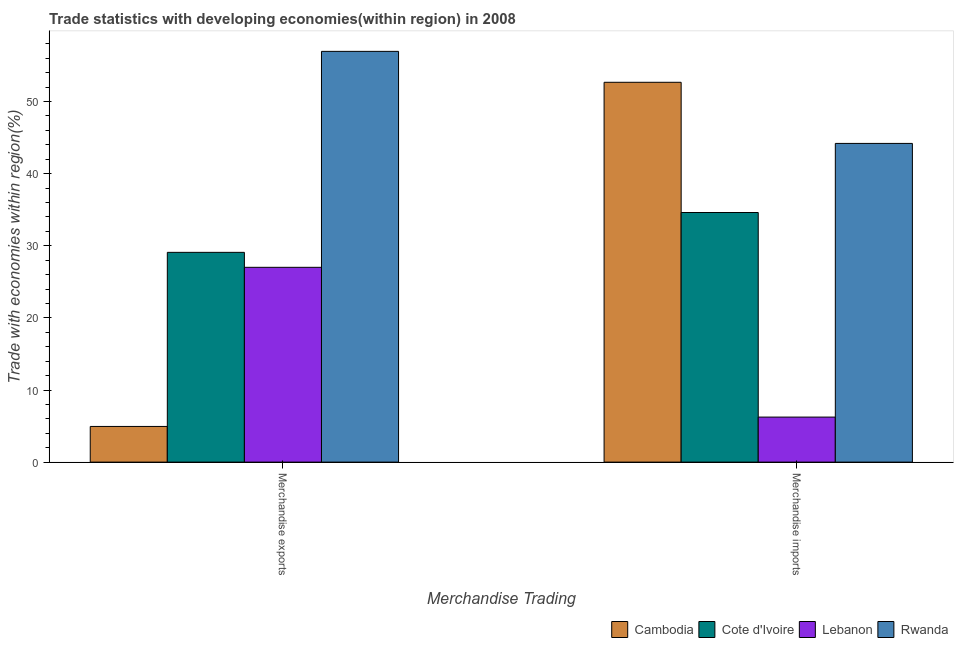How many different coloured bars are there?
Make the answer very short. 4. Are the number of bars per tick equal to the number of legend labels?
Offer a terse response. Yes. Are the number of bars on each tick of the X-axis equal?
Your answer should be compact. Yes. What is the merchandise imports in Lebanon?
Your answer should be very brief. 6.25. Across all countries, what is the maximum merchandise imports?
Ensure brevity in your answer.  52.67. Across all countries, what is the minimum merchandise exports?
Provide a short and direct response. 4.95. In which country was the merchandise imports maximum?
Offer a very short reply. Cambodia. In which country was the merchandise imports minimum?
Give a very brief answer. Lebanon. What is the total merchandise exports in the graph?
Your response must be concise. 118. What is the difference between the merchandise exports in Lebanon and that in Rwanda?
Make the answer very short. -29.94. What is the difference between the merchandise exports in Lebanon and the merchandise imports in Rwanda?
Your answer should be compact. -17.18. What is the average merchandise imports per country?
Make the answer very short. 34.43. What is the difference between the merchandise imports and merchandise exports in Lebanon?
Your answer should be compact. -20.76. What is the ratio of the merchandise exports in Rwanda to that in Lebanon?
Keep it short and to the point. 2.11. Is the merchandise imports in Cambodia less than that in Rwanda?
Offer a very short reply. No. What does the 3rd bar from the left in Merchandise imports represents?
Provide a short and direct response. Lebanon. What does the 2nd bar from the right in Merchandise imports represents?
Offer a very short reply. Lebanon. How many countries are there in the graph?
Ensure brevity in your answer.  4. Does the graph contain any zero values?
Offer a terse response. No. Does the graph contain grids?
Your answer should be compact. No. Where does the legend appear in the graph?
Your answer should be compact. Bottom right. How are the legend labels stacked?
Your answer should be very brief. Horizontal. What is the title of the graph?
Offer a very short reply. Trade statistics with developing economies(within region) in 2008. What is the label or title of the X-axis?
Make the answer very short. Merchandise Trading. What is the label or title of the Y-axis?
Provide a succinct answer. Trade with economies within region(%). What is the Trade with economies within region(%) of Cambodia in Merchandise exports?
Provide a succinct answer. 4.95. What is the Trade with economies within region(%) of Cote d'Ivoire in Merchandise exports?
Keep it short and to the point. 29.09. What is the Trade with economies within region(%) of Lebanon in Merchandise exports?
Keep it short and to the point. 27.01. What is the Trade with economies within region(%) in Rwanda in Merchandise exports?
Make the answer very short. 56.95. What is the Trade with economies within region(%) of Cambodia in Merchandise imports?
Offer a very short reply. 52.67. What is the Trade with economies within region(%) in Cote d'Ivoire in Merchandise imports?
Your answer should be compact. 34.61. What is the Trade with economies within region(%) of Lebanon in Merchandise imports?
Provide a succinct answer. 6.25. What is the Trade with economies within region(%) in Rwanda in Merchandise imports?
Offer a very short reply. 44.19. Across all Merchandise Trading, what is the maximum Trade with economies within region(%) in Cambodia?
Your answer should be very brief. 52.67. Across all Merchandise Trading, what is the maximum Trade with economies within region(%) of Cote d'Ivoire?
Provide a succinct answer. 34.61. Across all Merchandise Trading, what is the maximum Trade with economies within region(%) of Lebanon?
Your answer should be compact. 27.01. Across all Merchandise Trading, what is the maximum Trade with economies within region(%) in Rwanda?
Offer a very short reply. 56.95. Across all Merchandise Trading, what is the minimum Trade with economies within region(%) in Cambodia?
Offer a very short reply. 4.95. Across all Merchandise Trading, what is the minimum Trade with economies within region(%) in Cote d'Ivoire?
Your answer should be very brief. 29.09. Across all Merchandise Trading, what is the minimum Trade with economies within region(%) in Lebanon?
Provide a short and direct response. 6.25. Across all Merchandise Trading, what is the minimum Trade with economies within region(%) in Rwanda?
Make the answer very short. 44.19. What is the total Trade with economies within region(%) in Cambodia in the graph?
Your response must be concise. 57.61. What is the total Trade with economies within region(%) of Cote d'Ivoire in the graph?
Give a very brief answer. 63.7. What is the total Trade with economies within region(%) in Lebanon in the graph?
Offer a terse response. 33.26. What is the total Trade with economies within region(%) in Rwanda in the graph?
Provide a short and direct response. 101.14. What is the difference between the Trade with economies within region(%) in Cambodia in Merchandise exports and that in Merchandise imports?
Your response must be concise. -47.72. What is the difference between the Trade with economies within region(%) of Cote d'Ivoire in Merchandise exports and that in Merchandise imports?
Your response must be concise. -5.52. What is the difference between the Trade with economies within region(%) of Lebanon in Merchandise exports and that in Merchandise imports?
Your response must be concise. 20.76. What is the difference between the Trade with economies within region(%) of Rwanda in Merchandise exports and that in Merchandise imports?
Keep it short and to the point. 12.76. What is the difference between the Trade with economies within region(%) in Cambodia in Merchandise exports and the Trade with economies within region(%) in Cote d'Ivoire in Merchandise imports?
Your answer should be very brief. -29.66. What is the difference between the Trade with economies within region(%) of Cambodia in Merchandise exports and the Trade with economies within region(%) of Lebanon in Merchandise imports?
Your response must be concise. -1.3. What is the difference between the Trade with economies within region(%) in Cambodia in Merchandise exports and the Trade with economies within region(%) in Rwanda in Merchandise imports?
Offer a terse response. -39.25. What is the difference between the Trade with economies within region(%) in Cote d'Ivoire in Merchandise exports and the Trade with economies within region(%) in Lebanon in Merchandise imports?
Offer a terse response. 22.84. What is the difference between the Trade with economies within region(%) of Cote d'Ivoire in Merchandise exports and the Trade with economies within region(%) of Rwanda in Merchandise imports?
Make the answer very short. -15.11. What is the difference between the Trade with economies within region(%) in Lebanon in Merchandise exports and the Trade with economies within region(%) in Rwanda in Merchandise imports?
Your answer should be very brief. -17.18. What is the average Trade with economies within region(%) of Cambodia per Merchandise Trading?
Offer a terse response. 28.81. What is the average Trade with economies within region(%) in Cote d'Ivoire per Merchandise Trading?
Offer a terse response. 31.85. What is the average Trade with economies within region(%) of Lebanon per Merchandise Trading?
Give a very brief answer. 16.63. What is the average Trade with economies within region(%) in Rwanda per Merchandise Trading?
Your answer should be compact. 50.57. What is the difference between the Trade with economies within region(%) in Cambodia and Trade with economies within region(%) in Cote d'Ivoire in Merchandise exports?
Your answer should be very brief. -24.14. What is the difference between the Trade with economies within region(%) in Cambodia and Trade with economies within region(%) in Lebanon in Merchandise exports?
Ensure brevity in your answer.  -22.06. What is the difference between the Trade with economies within region(%) in Cambodia and Trade with economies within region(%) in Rwanda in Merchandise exports?
Make the answer very short. -52.01. What is the difference between the Trade with economies within region(%) in Cote d'Ivoire and Trade with economies within region(%) in Lebanon in Merchandise exports?
Keep it short and to the point. 2.08. What is the difference between the Trade with economies within region(%) in Cote d'Ivoire and Trade with economies within region(%) in Rwanda in Merchandise exports?
Keep it short and to the point. -27.87. What is the difference between the Trade with economies within region(%) in Lebanon and Trade with economies within region(%) in Rwanda in Merchandise exports?
Your response must be concise. -29.94. What is the difference between the Trade with economies within region(%) of Cambodia and Trade with economies within region(%) of Cote d'Ivoire in Merchandise imports?
Offer a very short reply. 18.06. What is the difference between the Trade with economies within region(%) of Cambodia and Trade with economies within region(%) of Lebanon in Merchandise imports?
Keep it short and to the point. 46.42. What is the difference between the Trade with economies within region(%) of Cambodia and Trade with economies within region(%) of Rwanda in Merchandise imports?
Offer a terse response. 8.47. What is the difference between the Trade with economies within region(%) in Cote d'Ivoire and Trade with economies within region(%) in Lebanon in Merchandise imports?
Offer a very short reply. 28.36. What is the difference between the Trade with economies within region(%) in Cote d'Ivoire and Trade with economies within region(%) in Rwanda in Merchandise imports?
Your response must be concise. -9.58. What is the difference between the Trade with economies within region(%) in Lebanon and Trade with economies within region(%) in Rwanda in Merchandise imports?
Your answer should be very brief. -37.95. What is the ratio of the Trade with economies within region(%) in Cambodia in Merchandise exports to that in Merchandise imports?
Your answer should be compact. 0.09. What is the ratio of the Trade with economies within region(%) in Cote d'Ivoire in Merchandise exports to that in Merchandise imports?
Your answer should be very brief. 0.84. What is the ratio of the Trade with economies within region(%) in Lebanon in Merchandise exports to that in Merchandise imports?
Provide a succinct answer. 4.32. What is the ratio of the Trade with economies within region(%) of Rwanda in Merchandise exports to that in Merchandise imports?
Keep it short and to the point. 1.29. What is the difference between the highest and the second highest Trade with economies within region(%) of Cambodia?
Give a very brief answer. 47.72. What is the difference between the highest and the second highest Trade with economies within region(%) of Cote d'Ivoire?
Offer a terse response. 5.52. What is the difference between the highest and the second highest Trade with economies within region(%) in Lebanon?
Your answer should be very brief. 20.76. What is the difference between the highest and the second highest Trade with economies within region(%) of Rwanda?
Your answer should be compact. 12.76. What is the difference between the highest and the lowest Trade with economies within region(%) of Cambodia?
Ensure brevity in your answer.  47.72. What is the difference between the highest and the lowest Trade with economies within region(%) of Cote d'Ivoire?
Keep it short and to the point. 5.52. What is the difference between the highest and the lowest Trade with economies within region(%) in Lebanon?
Your response must be concise. 20.76. What is the difference between the highest and the lowest Trade with economies within region(%) in Rwanda?
Keep it short and to the point. 12.76. 